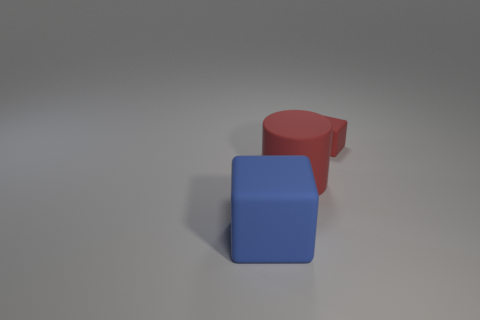Subtract all blue cubes. How many cubes are left? 1 Add 1 red cubes. How many objects exist? 4 Subtract 1 cubes. How many cubes are left? 1 Add 2 small red blocks. How many small red blocks are left? 3 Add 2 big blocks. How many big blocks exist? 3 Subtract 0 gray cubes. How many objects are left? 3 Subtract all cylinders. How many objects are left? 2 Subtract all purple blocks. Subtract all yellow cylinders. How many blocks are left? 2 Subtract all large red objects. Subtract all large gray metallic spheres. How many objects are left? 2 